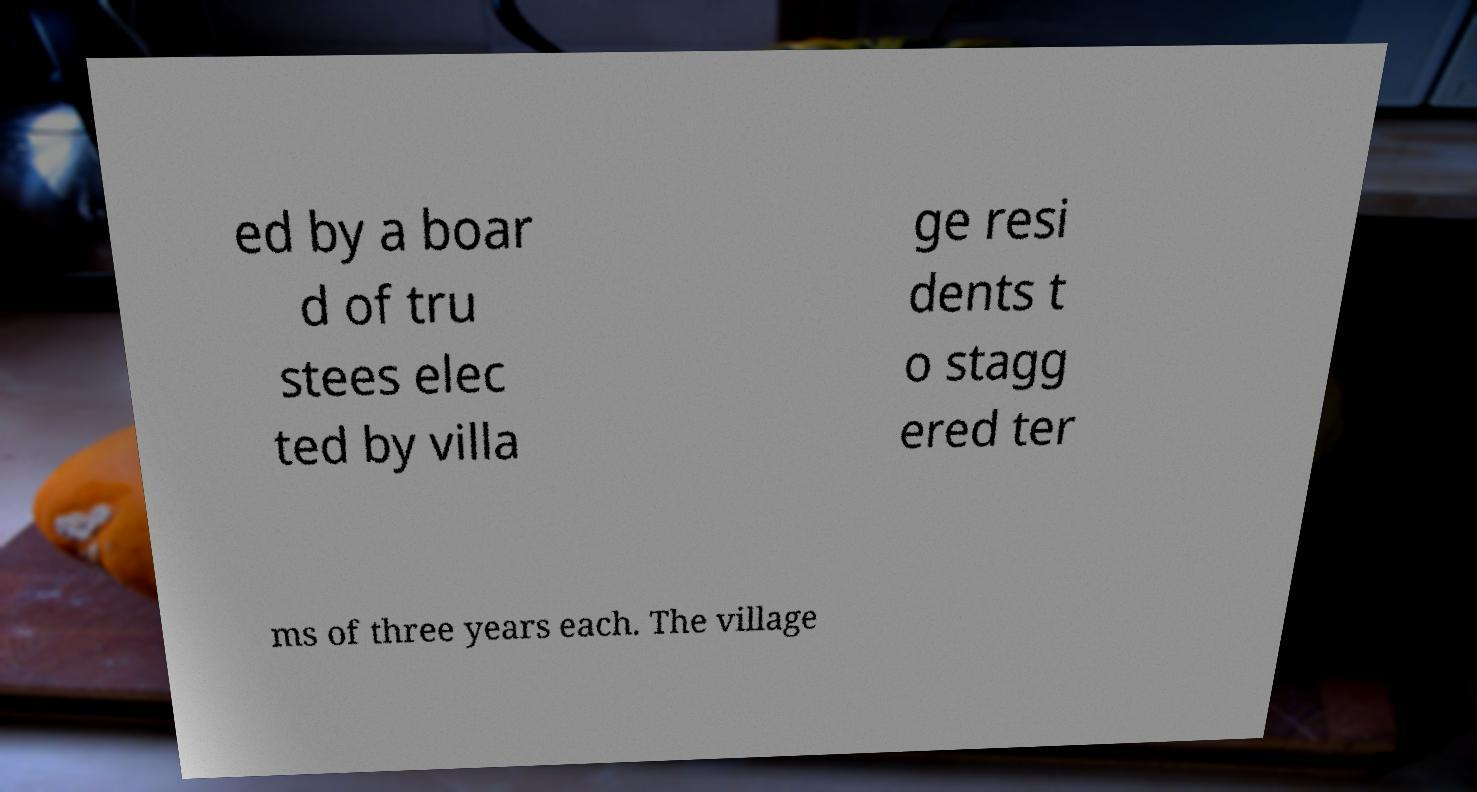Could you assist in decoding the text presented in this image and type it out clearly? ed by a boar d of tru stees elec ted by villa ge resi dents t o stagg ered ter ms of three years each. The village 